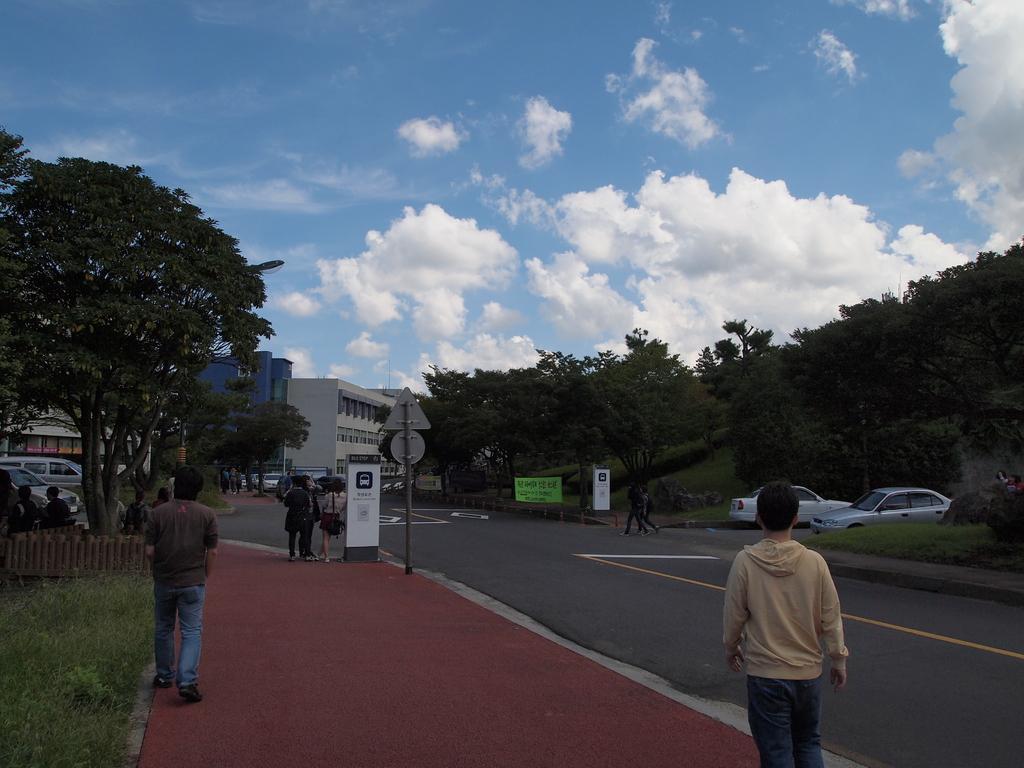Can you describe this image briefly? In the background we can see the clouds in the sky. In this picture we can see buildings, boards, trees, fence, people, vehicles, road, grass and few objects. 